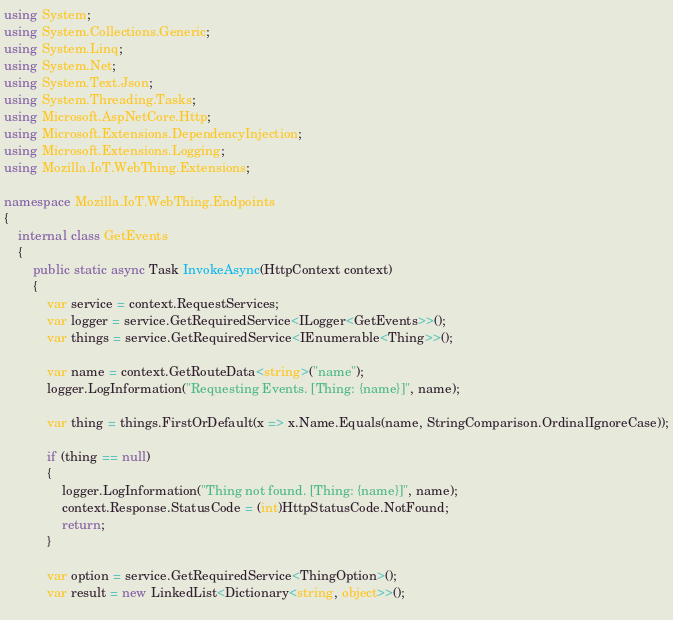Convert code to text. <code><loc_0><loc_0><loc_500><loc_500><_C#_>using System;
using System.Collections.Generic;
using System.Linq;
using System.Net;
using System.Text.Json;
using System.Threading.Tasks;
using Microsoft.AspNetCore.Http;
using Microsoft.Extensions.DependencyInjection;
using Microsoft.Extensions.Logging;
using Mozilla.IoT.WebThing.Extensions;

namespace Mozilla.IoT.WebThing.Endpoints
{
    internal class GetEvents
    {
        public static async Task InvokeAsync(HttpContext context)
        {
            var service = context.RequestServices;
            var logger = service.GetRequiredService<ILogger<GetEvents>>();
            var things = service.GetRequiredService<IEnumerable<Thing>>();
            
            var name = context.GetRouteData<string>("name");
            logger.LogInformation("Requesting Events. [Thing: {name}]", name);
            
            var thing = things.FirstOrDefault(x => x.Name.Equals(name, StringComparison.OrdinalIgnoreCase));

            if (thing == null)
            {
                logger.LogInformation("Thing not found. [Thing: {name}]", name);
                context.Response.StatusCode = (int)HttpStatusCode.NotFound;
                return;
            }
            
            var option = service.GetRequiredService<ThingOption>();
            var result = new LinkedList<Dictionary<string, object>>();
            </code> 